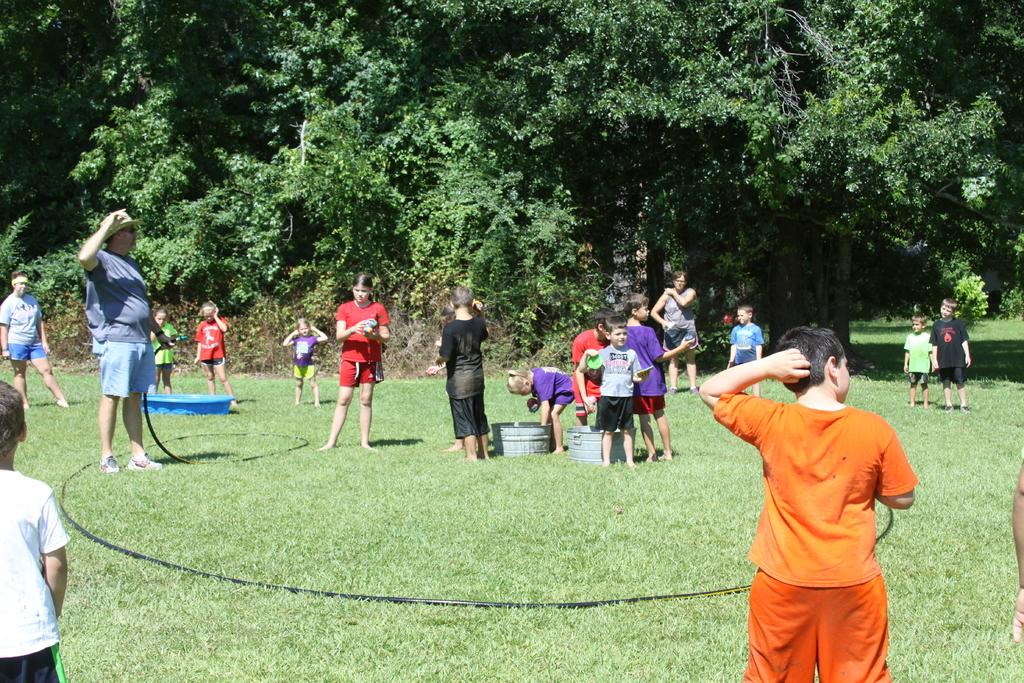What can be seen in the image? There are people standing in the image. What is at the bottom of the image? There is grass at the bottom of the image. What object can be found in the image? There is a pipe in the image. What is visible in the background of the image? There are trees in the background of the image. What type of breakfast is being served in the image? There is no breakfast present in the image; it features people standing, grass, a pipe, and trees in the background. What is the size of the pipe in the image? The size of the pipe cannot be determined from the image alone, as there is no reference point for comparison. 